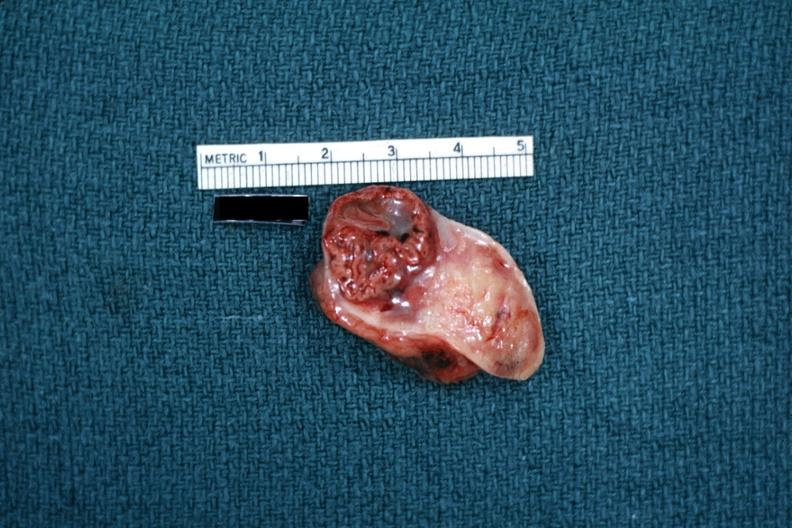s anencephaly present?
Answer the question using a single word or phrase. No 